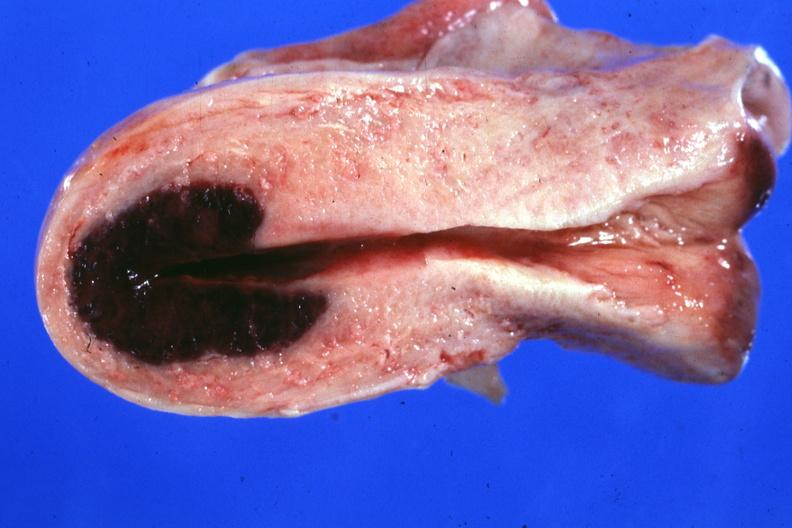what is lesion in dome of uterus said?
Answer the question using a single word or phrase. To have adenosis adenomyosis hemorrhage probably due to shock 